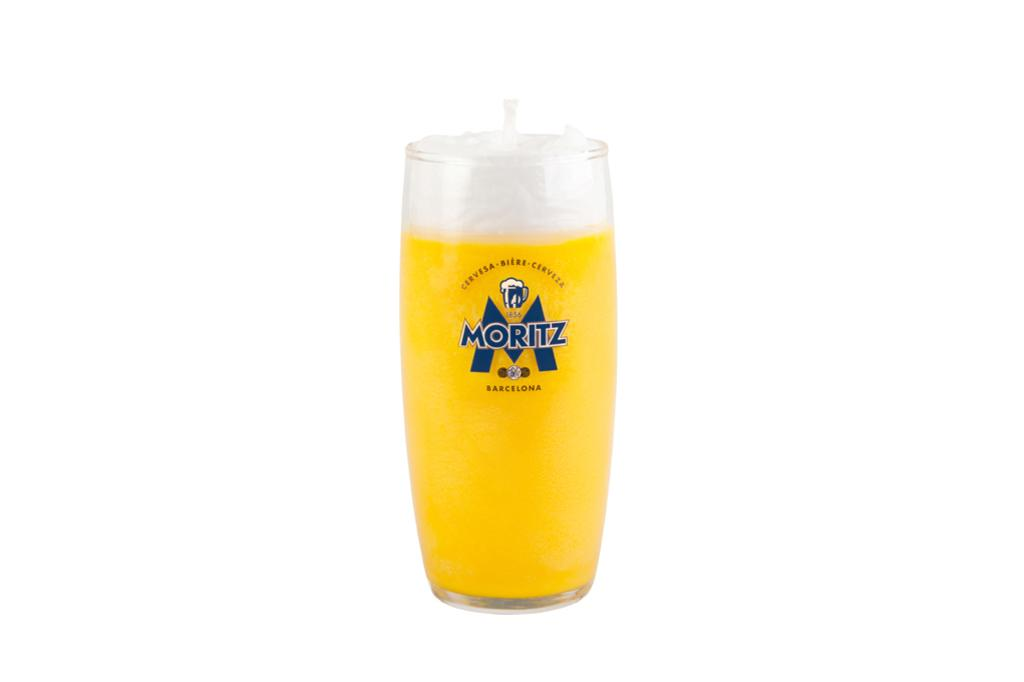<image>
Create a compact narrative representing the image presented. A glass that is labeled Moritz is full of beer. 